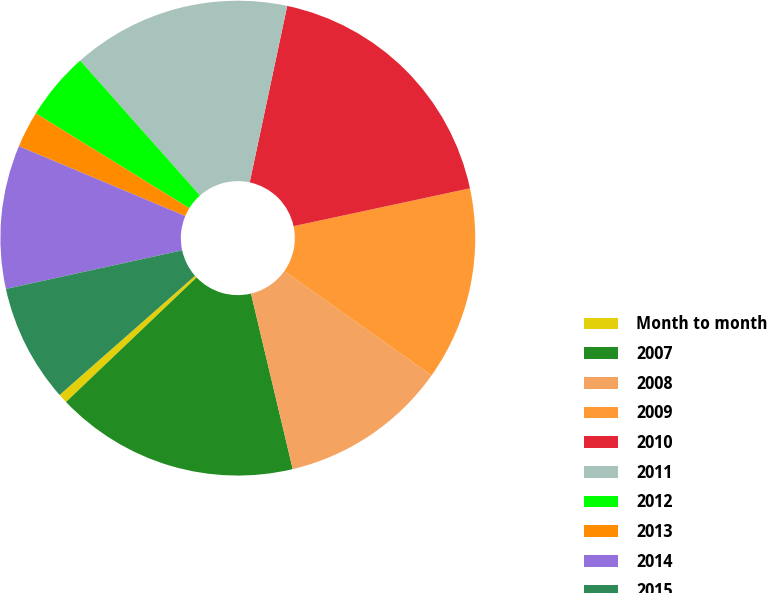Convert chart to OTSL. <chart><loc_0><loc_0><loc_500><loc_500><pie_chart><fcel>Month to month<fcel>2007<fcel>2008<fcel>2009<fcel>2010<fcel>2011<fcel>2012<fcel>2013<fcel>2014<fcel>2015<nl><fcel>0.64%<fcel>16.59%<fcel>11.47%<fcel>13.18%<fcel>18.3%<fcel>14.89%<fcel>4.64%<fcel>2.48%<fcel>9.76%<fcel>8.05%<nl></chart> 